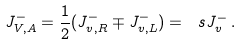Convert formula to latex. <formula><loc_0><loc_0><loc_500><loc_500>J ^ { - } _ { V , A } = \frac { 1 } { 2 } ( J ^ { - } _ { v , R } \mp J ^ { - } _ { v , L } ) = \ s J ^ { - } _ { v } \, .</formula> 